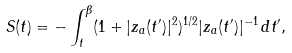Convert formula to latex. <formula><loc_0><loc_0><loc_500><loc_500>S ( t ) = - \int ^ { \beta } _ { t } ( 1 + | z _ { a } ( t ^ { \prime } ) | ^ { 2 } ) ^ { 1 / 2 } | z _ { a } ( t ^ { \prime } ) | ^ { - 1 } \, d t ^ { \prime } ,</formula> 